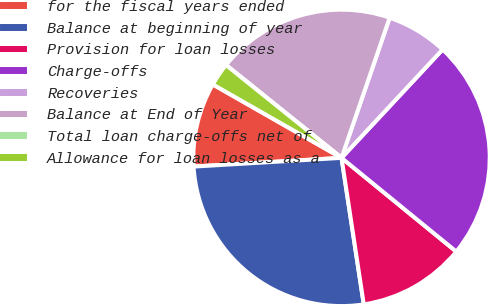Convert chart to OTSL. <chart><loc_0><loc_0><loc_500><loc_500><pie_chart><fcel>for the fiscal years ended<fcel>Balance at beginning of year<fcel>Provision for loan losses<fcel>Charge-offs<fcel>Recoveries<fcel>Balance at End of Year<fcel>Total loan charge-offs net of<fcel>Allowance for loan losses as a<nl><fcel>9.19%<fcel>26.46%<fcel>11.7%<fcel>23.95%<fcel>6.68%<fcel>19.49%<fcel>0.0%<fcel>2.52%<nl></chart> 